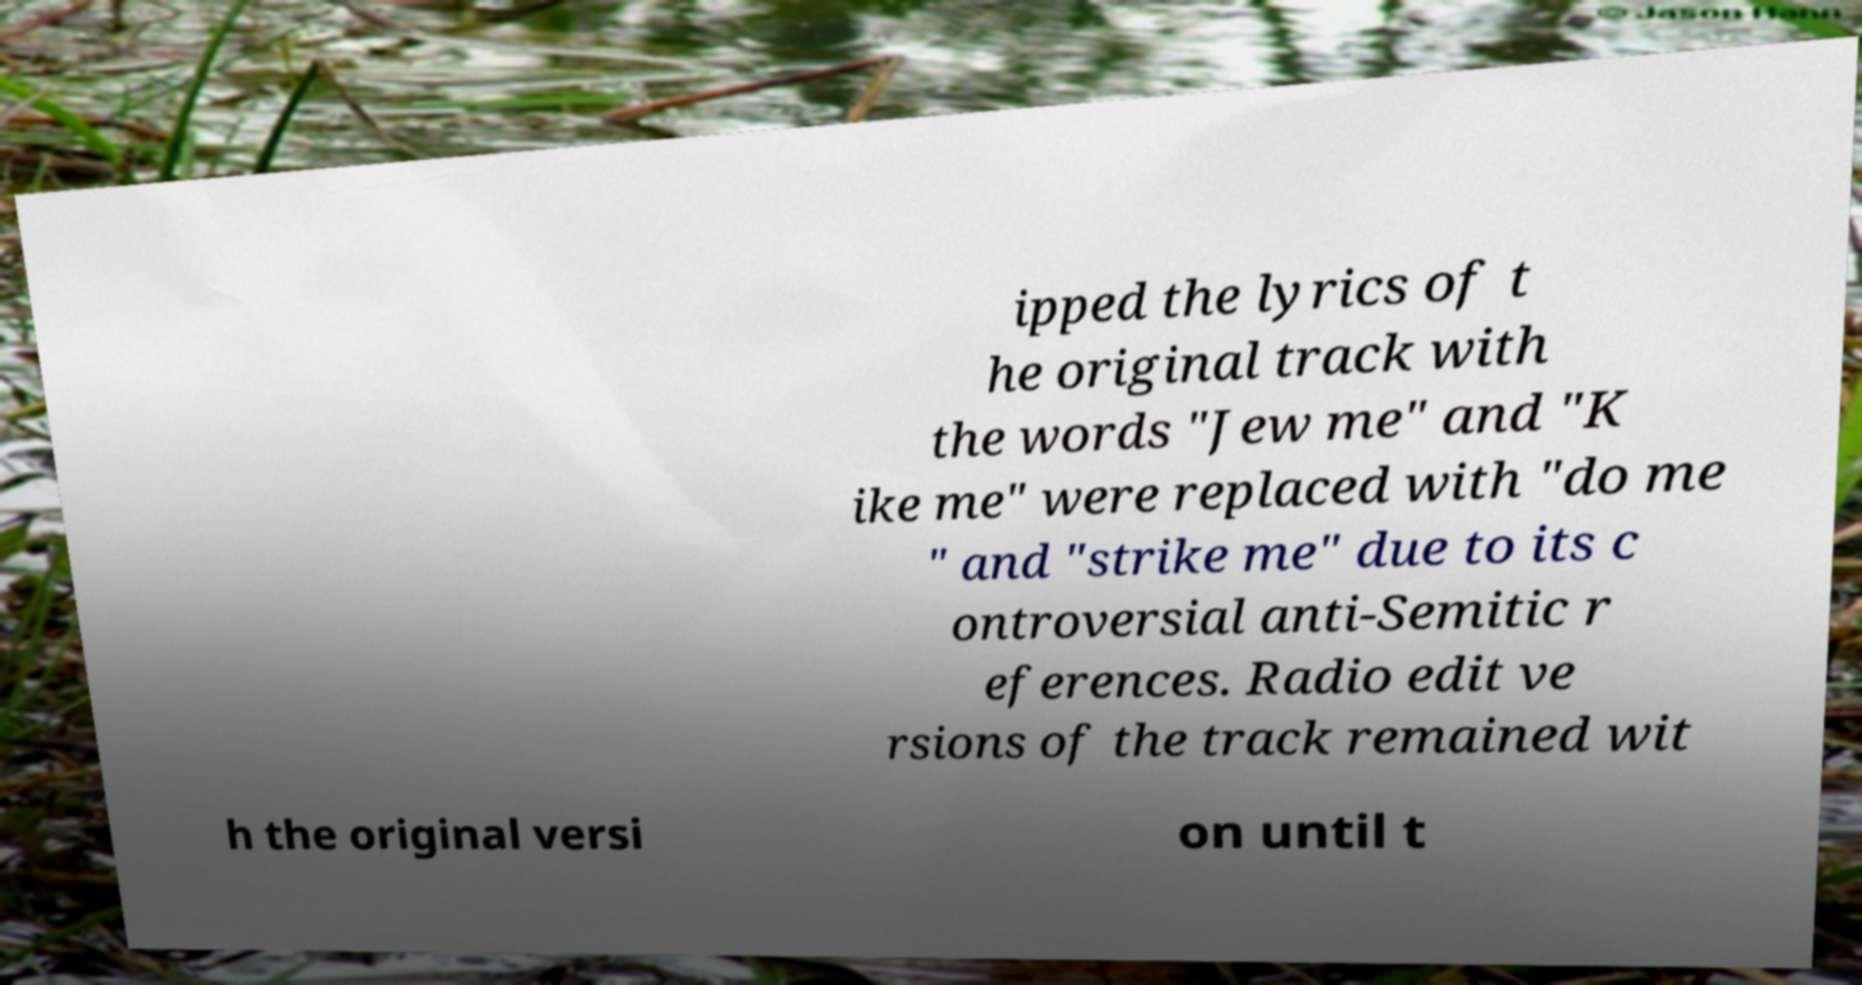What messages or text are displayed in this image? I need them in a readable, typed format. ipped the lyrics of t he original track with the words "Jew me" and "K ike me" were replaced with "do me " and "strike me" due to its c ontroversial anti-Semitic r eferences. Radio edit ve rsions of the track remained wit h the original versi on until t 